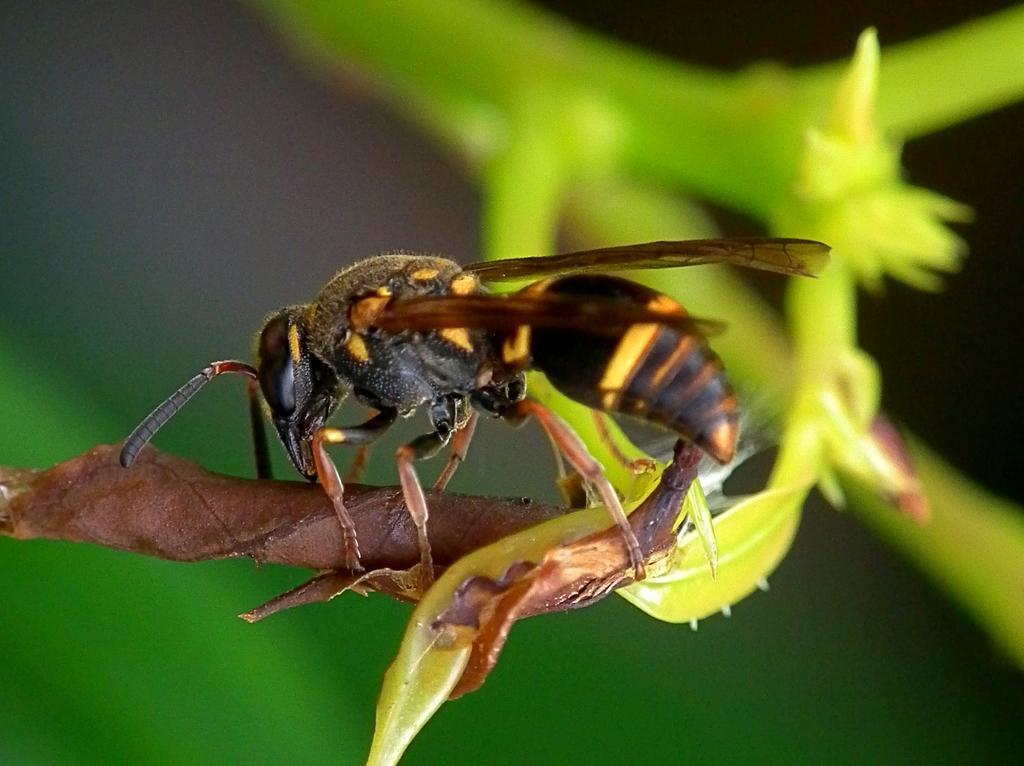Can you describe this image briefly? In the foreground of the picture there is an insect on stem. The background is blurred. 